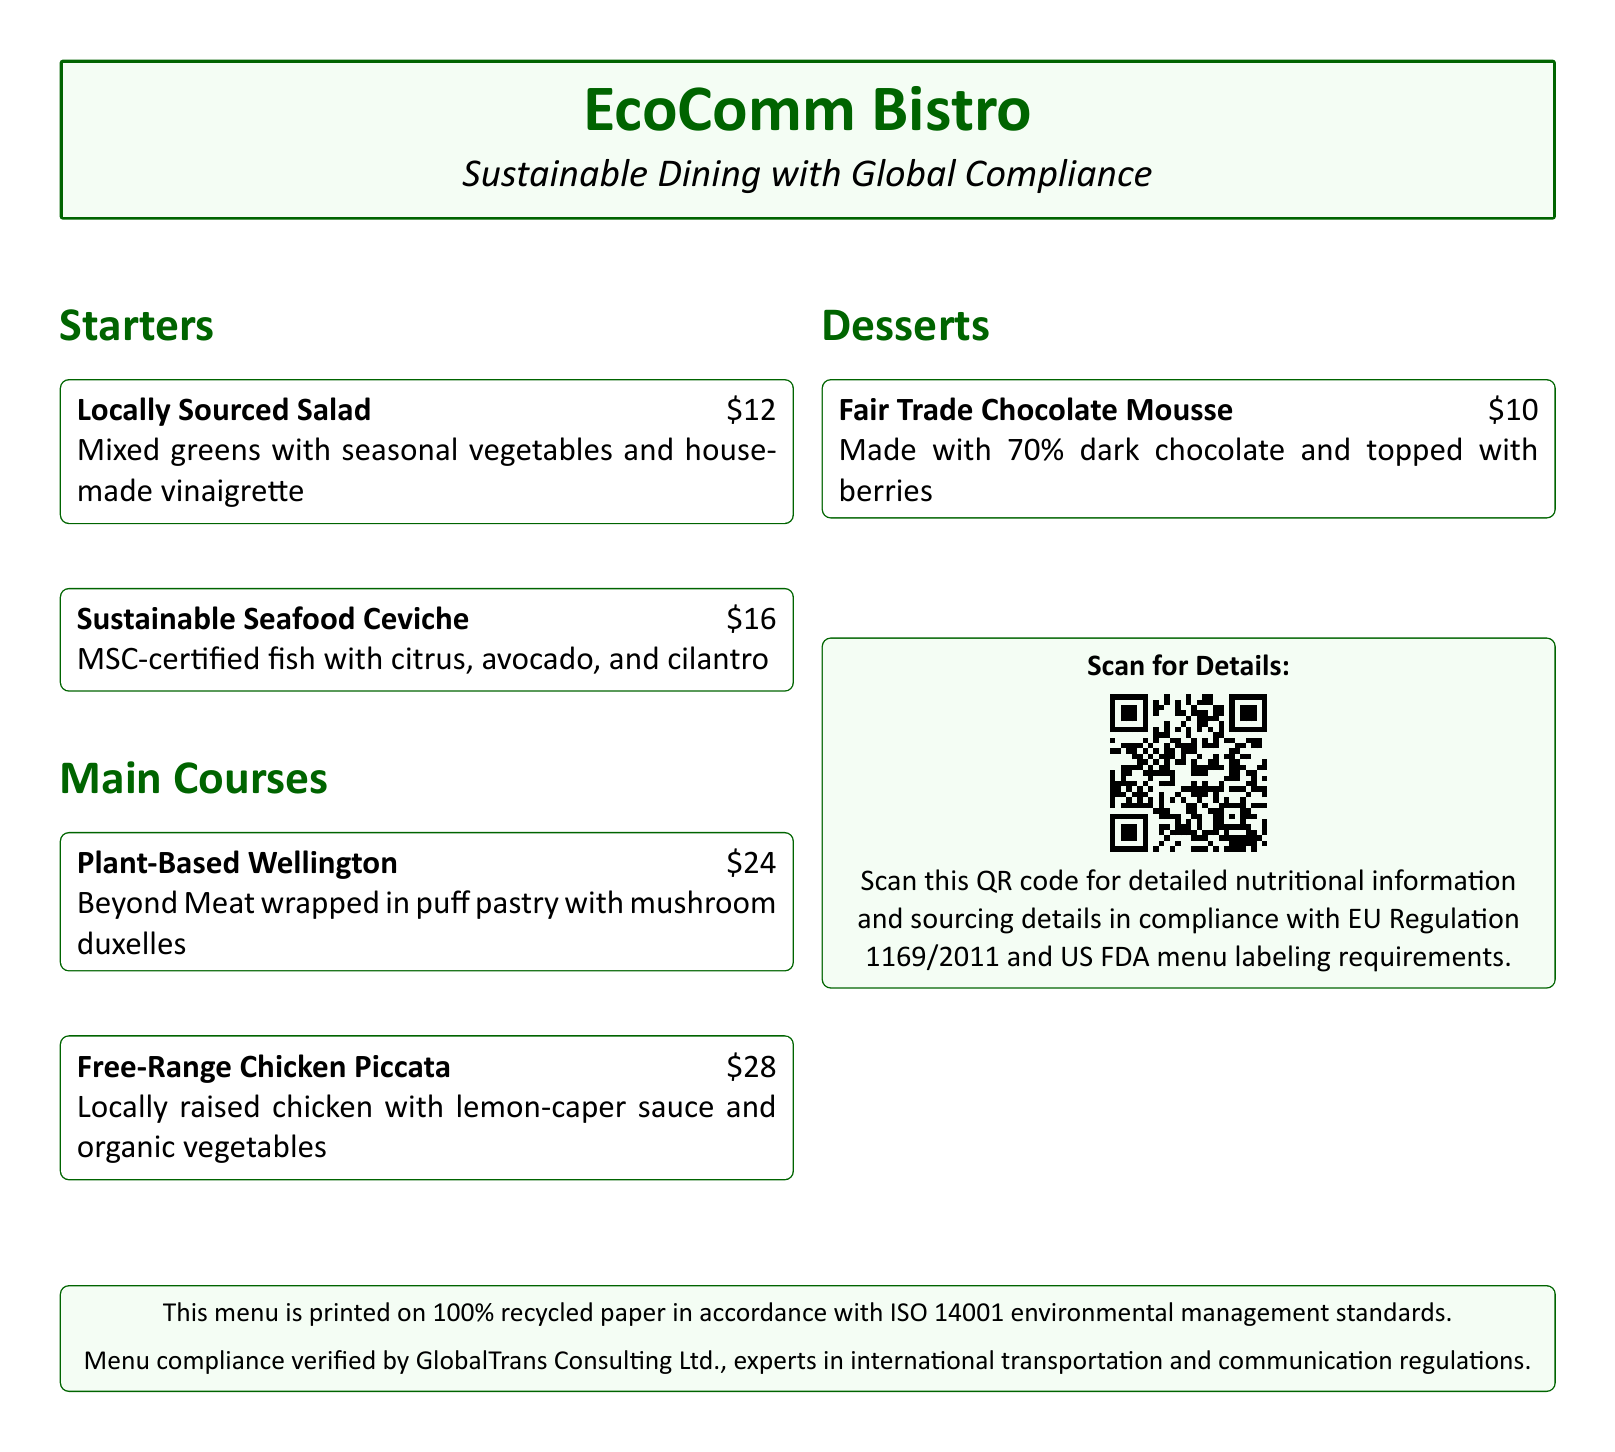What is the name of the restaurant? The name of the restaurant is prominently featured at the top of the document.
Answer: EcoComm Bistro What is included in the Locally Sourced Salad? The description provides details about the salad's ingredients.
Answer: Mixed greens with seasonal vegetables and house-made vinaigrette How much does the Plant-Based Wellington cost? The menu lists the price for the Plant-Based Wellington in the main courses section.
Answer: $24 What certification does the Sustainable Seafood Ceviche hold? The menu specifies the certification related to the seafood used.
Answer: MSC-certified What type of paper is the menu printed on? The document mentions the type of paper used in the printing section.
Answer: 100% recycled paper What regulations does the QR code comply with? The explanation with the QR code states specific compliance regulations.
Answer: EU Regulation 1169/2011 and US FDA menu labeling Who verified the compliance of the menu? The bottom section of the document names the verifying organization.
Answer: GlobalTrans Consulting Ltd What dessert is made with Fair Trade chocolate? The dessert section specifies which dessert features Fair Trade chocolate.
Answer: Fair Trade Chocolate Mousse How many main courses are listed on the menu? The document provides a count of the main course options presented.
Answer: Two 